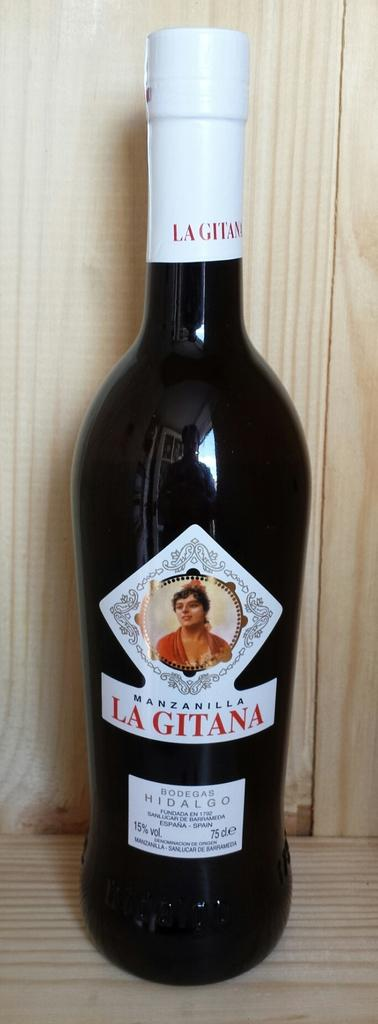<image>
Offer a succinct explanation of the picture presented. bottle of manzanilla la gitana on a wood shelf 